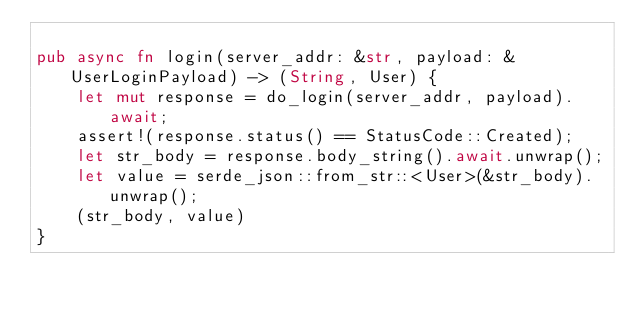Convert code to text. <code><loc_0><loc_0><loc_500><loc_500><_Rust_>
pub async fn login(server_addr: &str, payload: &UserLoginPayload) -> (String, User) {
    let mut response = do_login(server_addr, payload).await;
    assert!(response.status() == StatusCode::Created);
    let str_body = response.body_string().await.unwrap();
    let value = serde_json::from_str::<User>(&str_body).unwrap();
    (str_body, value)
}
</code> 